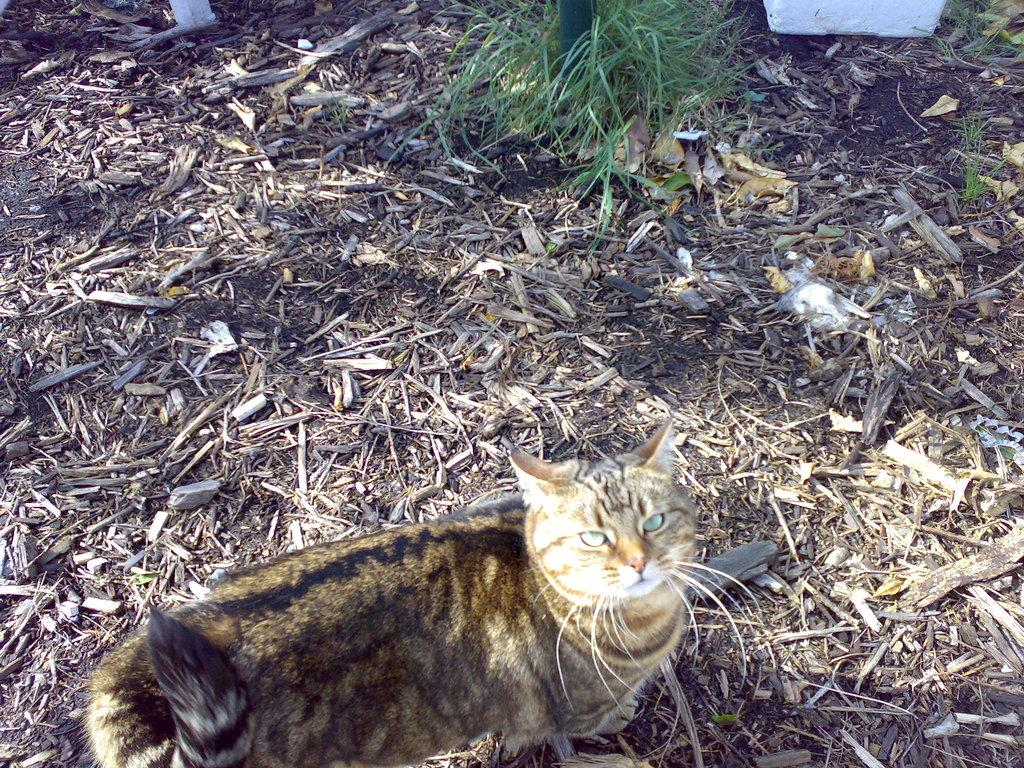What animal is at the bottom of the picture? There is a cat at the bottom of the picture. What is the cat doing in the image? The cat is looking at the camera. What can be seen in the background of the picture? There are twigs in the background of the picture. What type of vegetation is visible at the top of the picture? There is grass visible at the top of the picture. What is the color of the object at the top of the picture? There is an object in white color at the top of the picture. How does the cat use the can to lock the end of the twigs? There is no can or lock present in the image, and the cat is not interacting with the twigs in any way. 